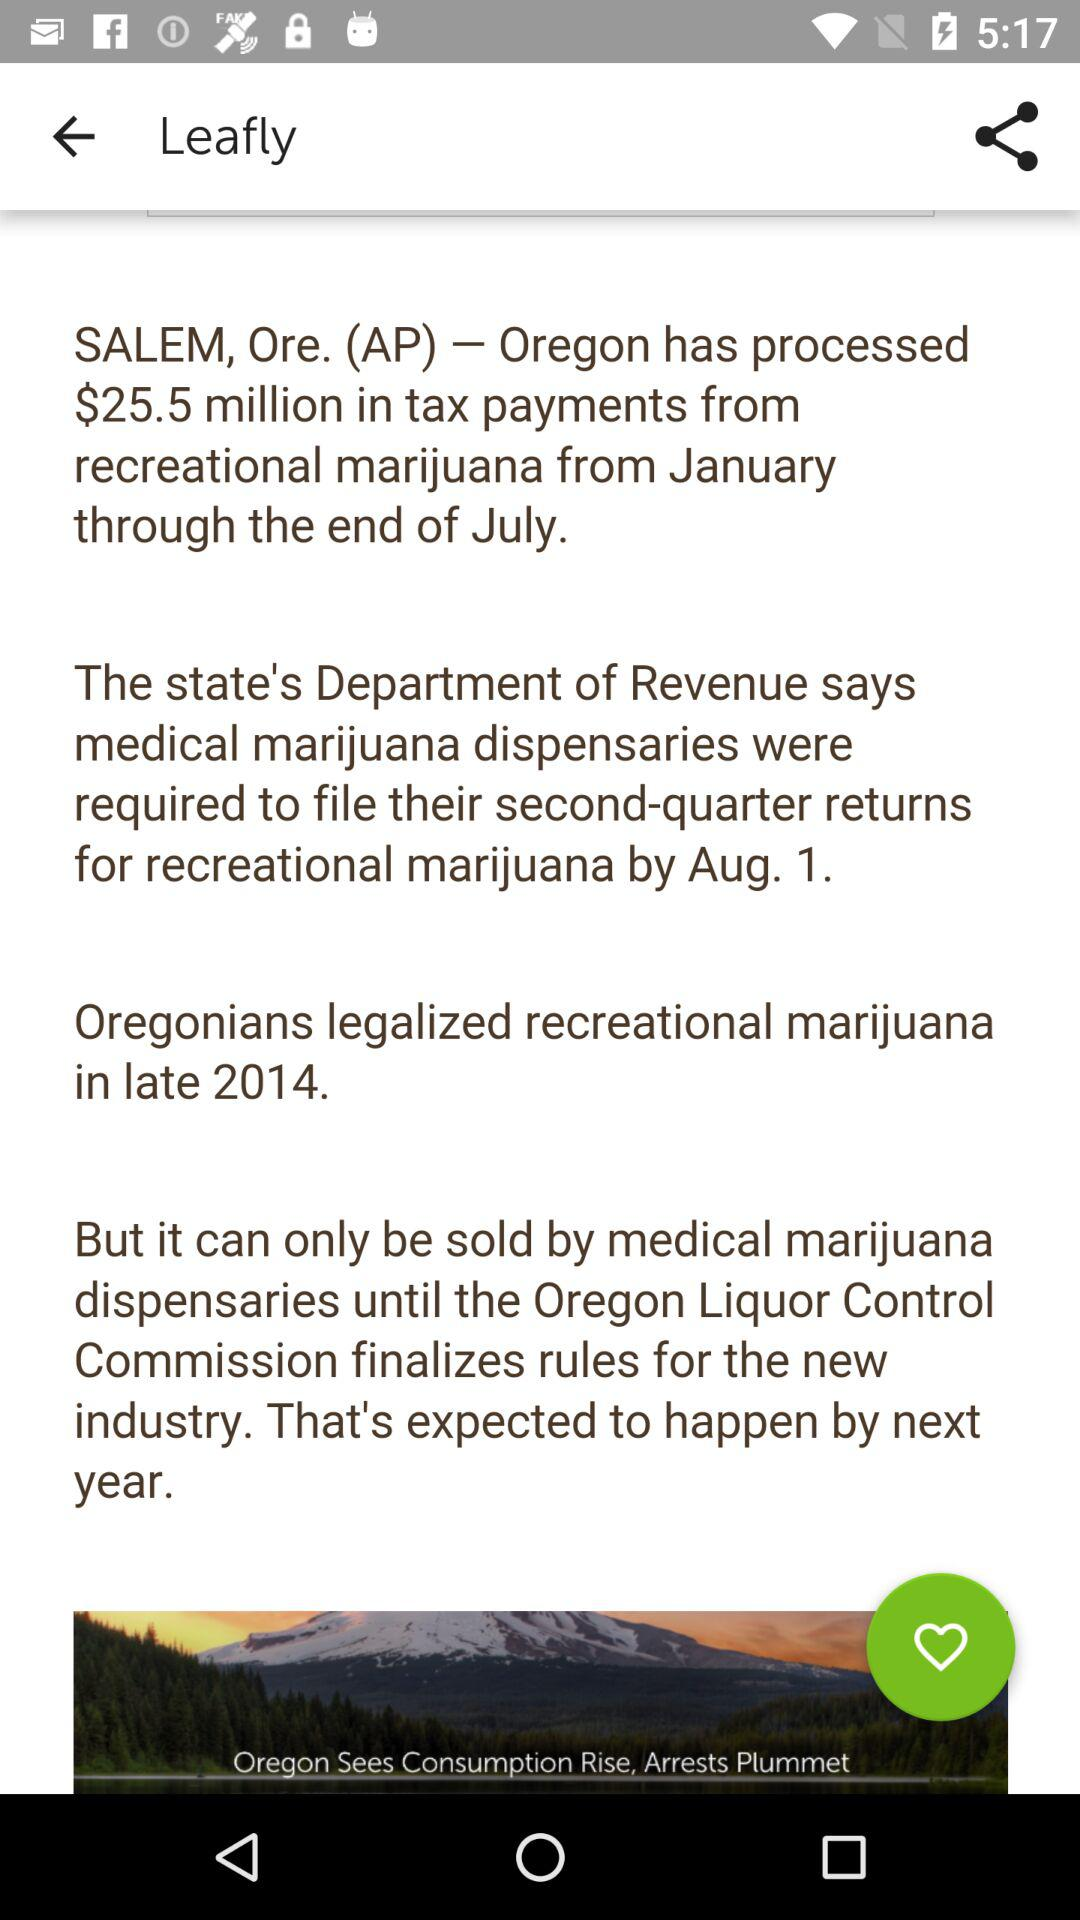What is the total amount of tax payments processed from recreational marijuana from January through the end of July? The total amount of tax payments processed from recreational marijuana from January through the end of July is $25.5 million. 